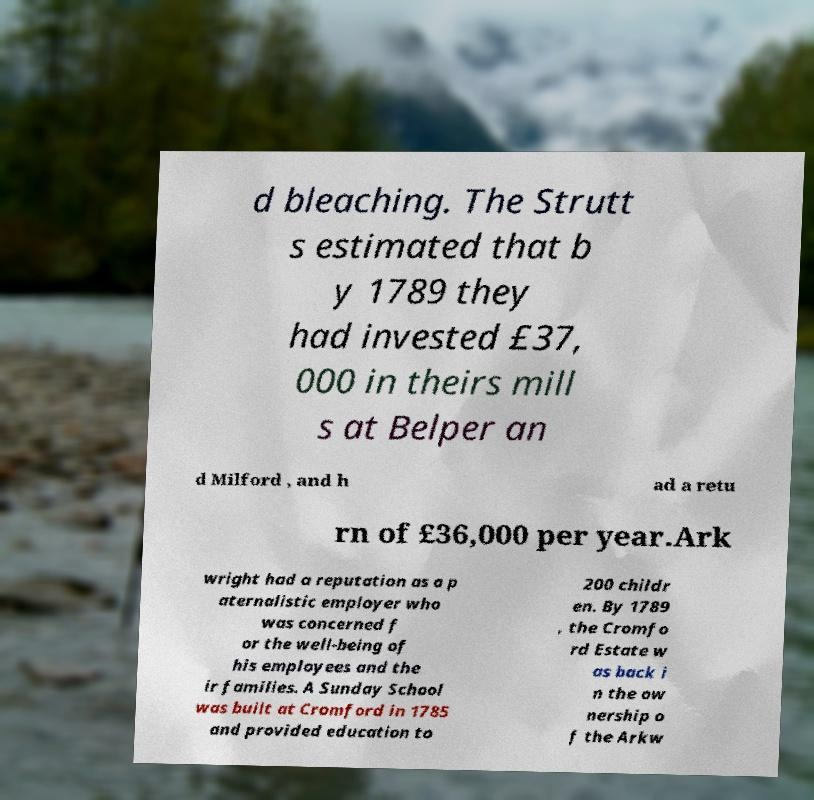Could you extract and type out the text from this image? d bleaching. The Strutt s estimated that b y 1789 they had invested £37, 000 in theirs mill s at Belper an d Milford , and h ad a retu rn of £36,000 per year.Ark wright had a reputation as a p aternalistic employer who was concerned f or the well-being of his employees and the ir families. A Sunday School was built at Cromford in 1785 and provided education to 200 childr en. By 1789 , the Cromfo rd Estate w as back i n the ow nership o f the Arkw 